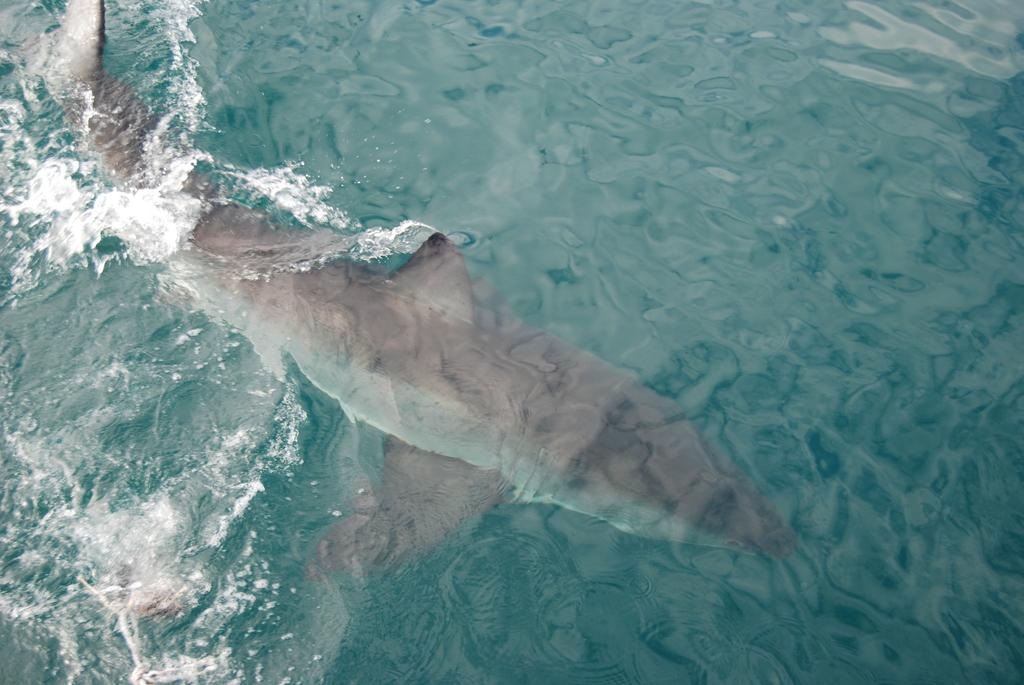What animal is the main subject of the image? There is a whale in the image. What color is the whale? The whale is black in color. Where is the whale located in the image? The whale is in the water. How many cobwebs can be seen on the whale in the image? There are no cobwebs present on the whale in the image, as it is in the water. 